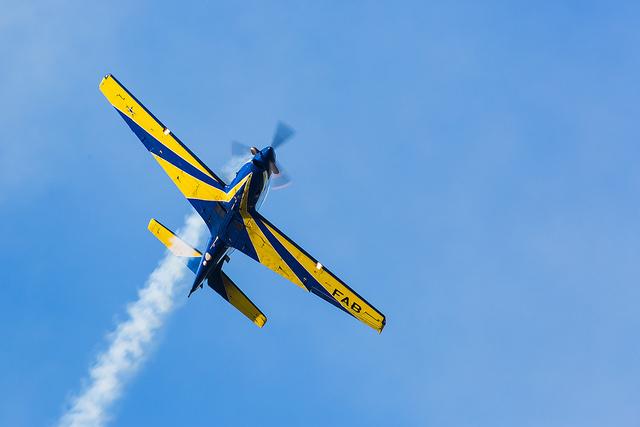What does the wing of the plane say?
Quick response, please. Fab. Is it cloudy?
Quick response, please. No. What colors are the plane?
Concise answer only. Blue and yellow. 